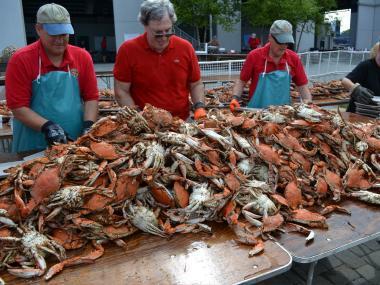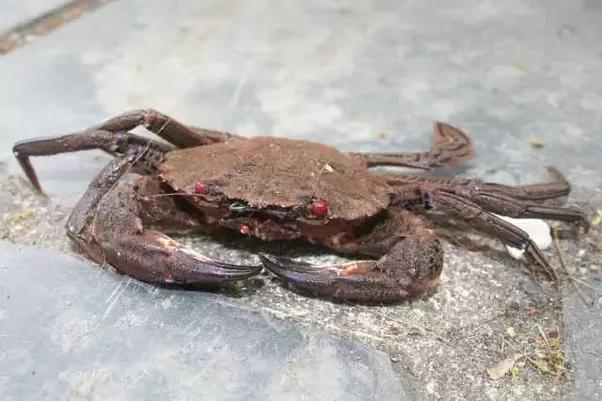The first image is the image on the left, the second image is the image on the right. For the images shown, is this caption "In the right image there is a single crab facing the camera." true? Answer yes or no. Yes. The first image is the image on the left, the second image is the image on the right. For the images displayed, is the sentence "Five or fewer crab bodies are visible." factually correct? Answer yes or no. No. 